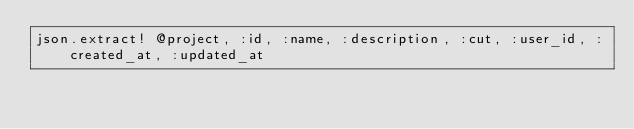Convert code to text. <code><loc_0><loc_0><loc_500><loc_500><_Ruby_>json.extract! @project, :id, :name, :description, :cut, :user_id, :created_at, :updated_at
</code> 